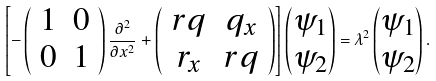Convert formula to latex. <formula><loc_0><loc_0><loc_500><loc_500>\left [ - \left ( \begin{array} { c c } 1 & 0 \\ 0 & 1 \end{array} \right ) \frac { \partial ^ { 2 } } { \partial x ^ { 2 } } + \left ( \begin{array} { c c } r q & q _ { x } \\ r _ { x } & r q \end{array} \right ) \right ] \begin{pmatrix} \psi _ { 1 } \\ \psi _ { 2 } \end{pmatrix} = \lambda ^ { 2 } \begin{pmatrix} \psi _ { 1 } \\ \psi _ { 2 } \end{pmatrix} .</formula> 